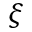<formula> <loc_0><loc_0><loc_500><loc_500>\xi</formula> 